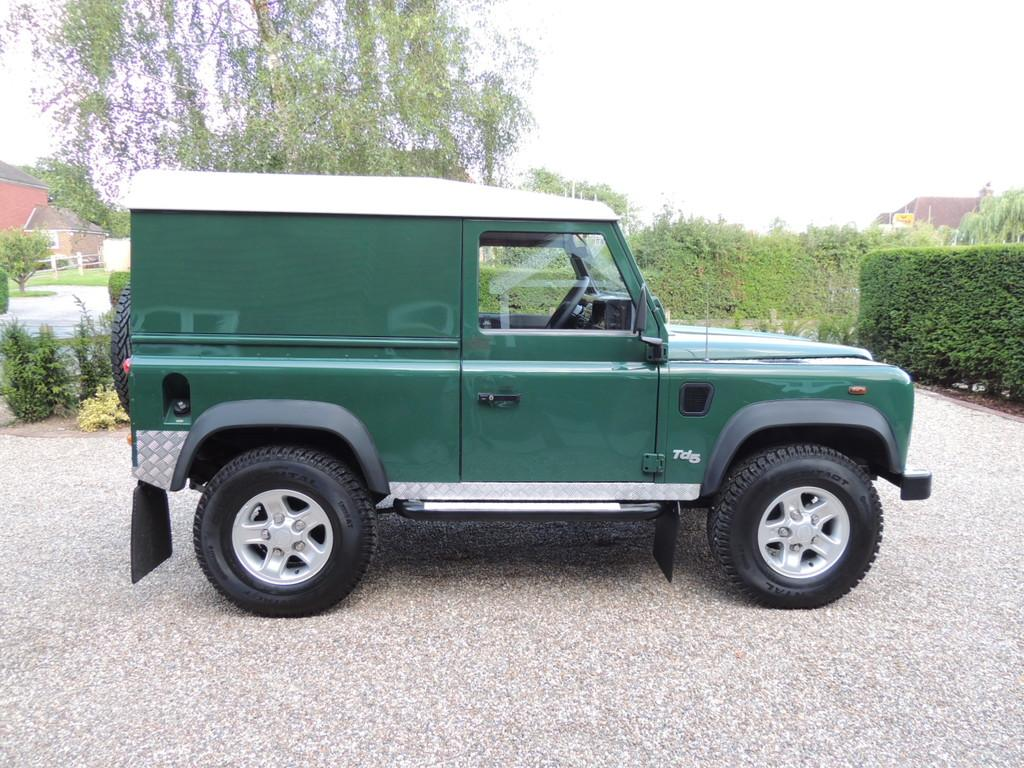What type of vehicle is in the middle of the image? There is a green color jeep in the middle of the image. What can be seen on the right side of the image? There are bushes on the right side of the image. What type of vegetation is on the left side of the image? There are trees on the left side of the image. What is visible at the top of the image? The sky is visible at the top of the image. What is the manager's opinion about the letter in the image? There is no letter or manager present in the image, so it is not possible to answer that question. 